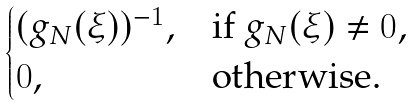<formula> <loc_0><loc_0><loc_500><loc_500>\begin{cases} ( g _ { N } ( \xi ) ) ^ { - 1 } , & \text {if } g _ { N } ( \xi ) \neq 0 , \\ 0 , & \text {otherwise} . \end{cases}</formula> 